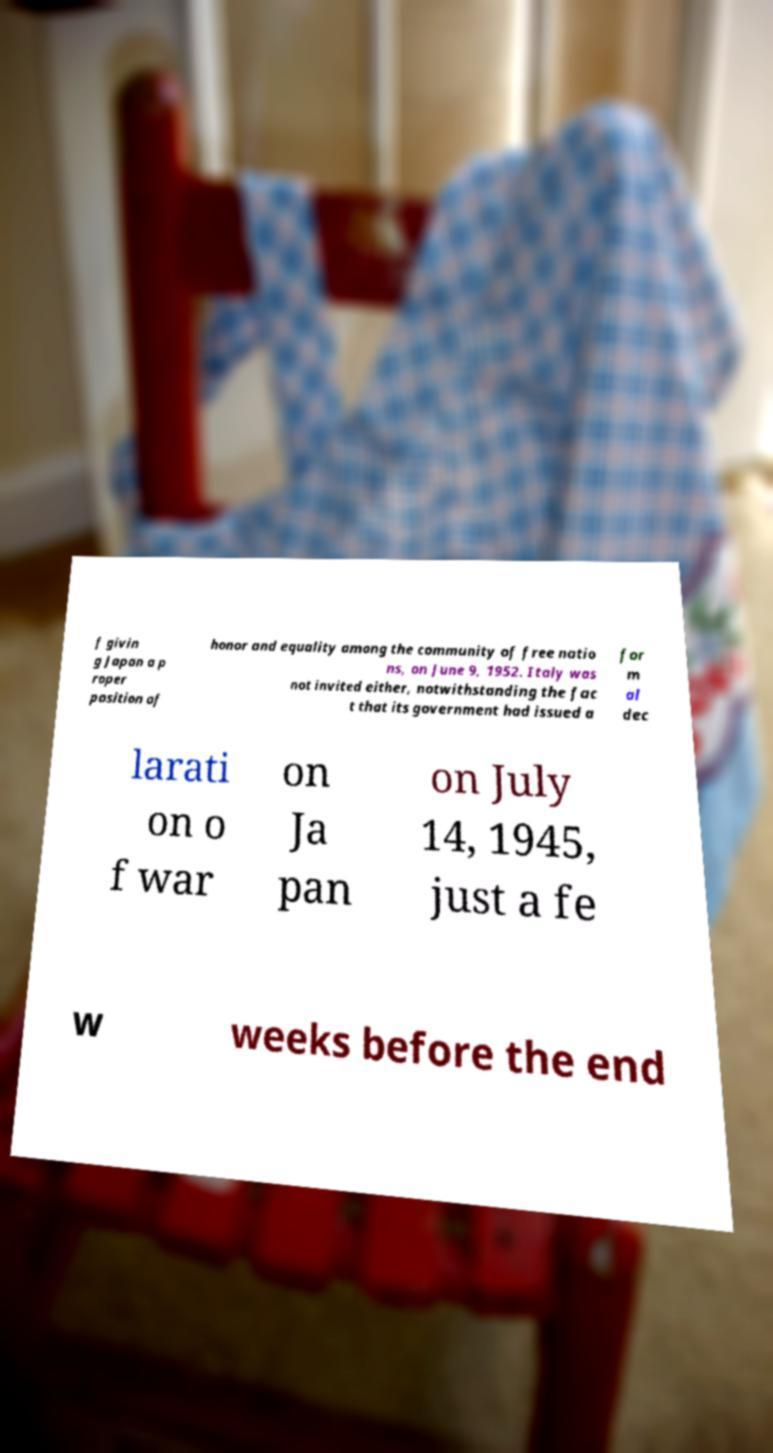Can you read and provide the text displayed in the image?This photo seems to have some interesting text. Can you extract and type it out for me? f givin g Japan a p roper position of honor and equality among the community of free natio ns, on June 9, 1952. Italy was not invited either, notwithstanding the fac t that its government had issued a for m al dec larati on o f war on Ja pan on July 14, 1945, just a fe w weeks before the end 